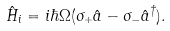Convert formula to latex. <formula><loc_0><loc_0><loc_500><loc_500>\hat { H } _ { i } = i \hbar { \Omega } ( \sigma _ { + } \hat { a } - \sigma _ { - } \hat { a } ^ { \dagger } ) .</formula> 